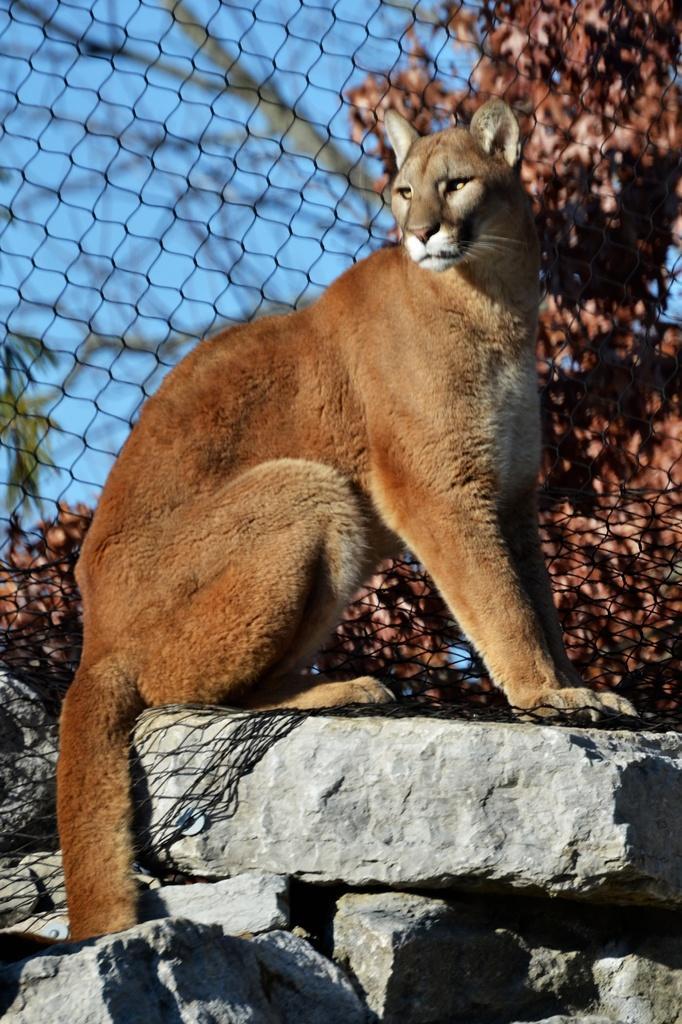Describe this image in one or two sentences. In this image we can see there is a lioness on the rocks, behind that there is a net fence and trees. 